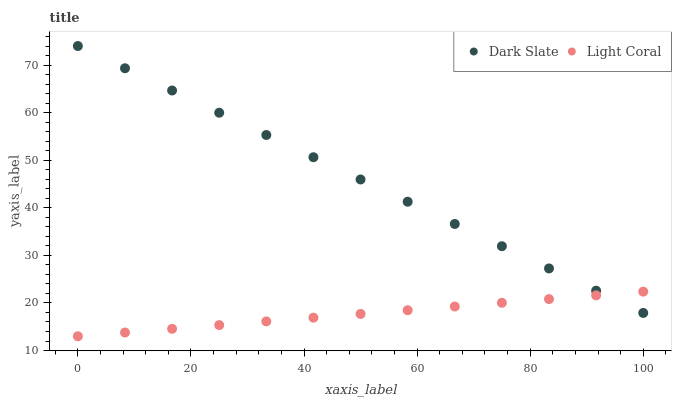Does Light Coral have the minimum area under the curve?
Answer yes or no. Yes. Does Dark Slate have the maximum area under the curve?
Answer yes or no. Yes. Does Dark Slate have the minimum area under the curve?
Answer yes or no. No. Is Light Coral the smoothest?
Answer yes or no. Yes. Is Dark Slate the roughest?
Answer yes or no. Yes. Is Dark Slate the smoothest?
Answer yes or no. No. Does Light Coral have the lowest value?
Answer yes or no. Yes. Does Dark Slate have the lowest value?
Answer yes or no. No. Does Dark Slate have the highest value?
Answer yes or no. Yes. Does Light Coral intersect Dark Slate?
Answer yes or no. Yes. Is Light Coral less than Dark Slate?
Answer yes or no. No. Is Light Coral greater than Dark Slate?
Answer yes or no. No. 